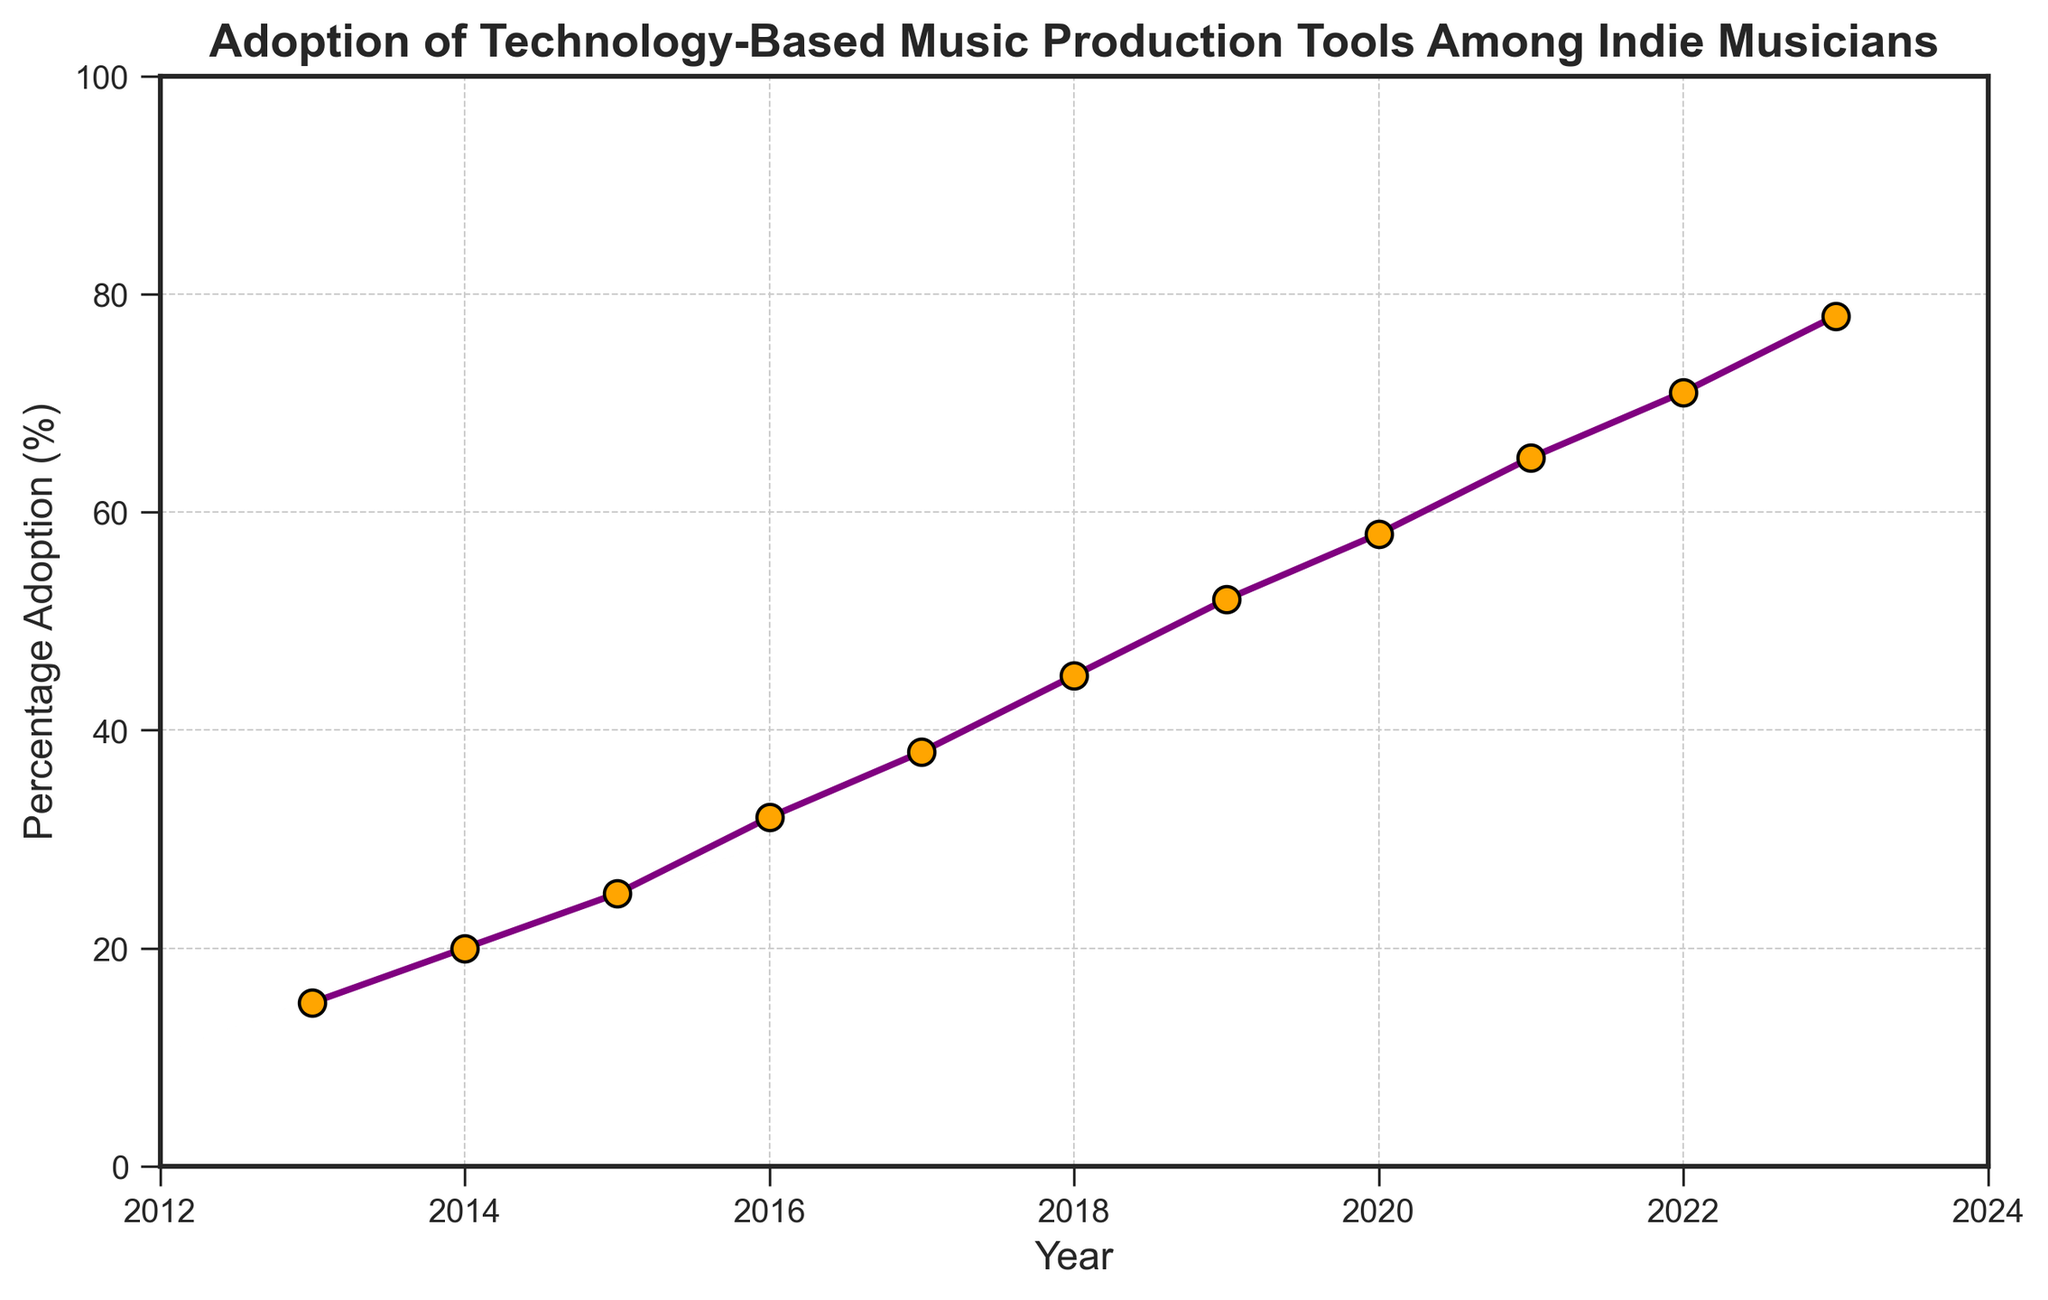What is the percentage adoption in 2013 and 2023? Look at the points on the line plot corresponding to the years 2013 and 2023. In 2013, the adoption is at 15%, and in 2023, it is at 78%.
Answer: 15% in 2013 and 78% in 2023 By how much did the percentage adoption change from 2013 to 2014? Subtract the percentage adoption in 2013 (15%) from the adoption in 2014 (20%). The difference is 20% - 15%.
Answer: 5% Which year experienced the highest percentage jump in adoption compared to the previous year? Calculate the differences between each consecutive year. The highest difference is between 2015 (25%) and 2016 (32%), with a 7% increase.
Answer: 2016 What is the average adoption percentage from 2013 to 2023? Sum all the adoption percentages from 2013 to 2023 and divide by the number of years, which is 11. Total is 15 + 20 + 25 + 32 + 38 + 45 + 52 + 58 + 65 + 71 + 78 = 499. Average is 499 / 11.
Answer: Approximately 45.36% How many times did the percentage adoption increase by 10% or more from one year to the next? Compare the adoption percentage year over year to see increases of 10% or more. The years 2016 (7%), 2017 (6%), 2018 (7%), and 2023 (7%) had increases less than 10%. The others had an increase of over 10%.
Answer: 7 times What is the overall trend of the percentage adoption from 2013 to 2023? Observe the overall slope of the line plot. The trend is consistently upward, indicating increasing adoption year over year.
Answer: Upward trend Which two consecutive years had the smallest increase in adoption percentage? Calculate the year-to-year differences and find the smallest one. The smallest increase is between 2016 (32%) and 2017 (38%), which is 6%.
Answer: Between 2016 and 2017 During which year did the adoption percentage surpass 50%? Observe the plot where the adoption percentage crosses the 50% mark. This happens in 2019 when the adoption reaches 52%.
Answer: 2019 What colors are used for the marker and line in the plot? Based on the visual attributes, the markers are filled with orange and bordered with black, while the line is purple.
Answer: Orange and black markers, purple line 